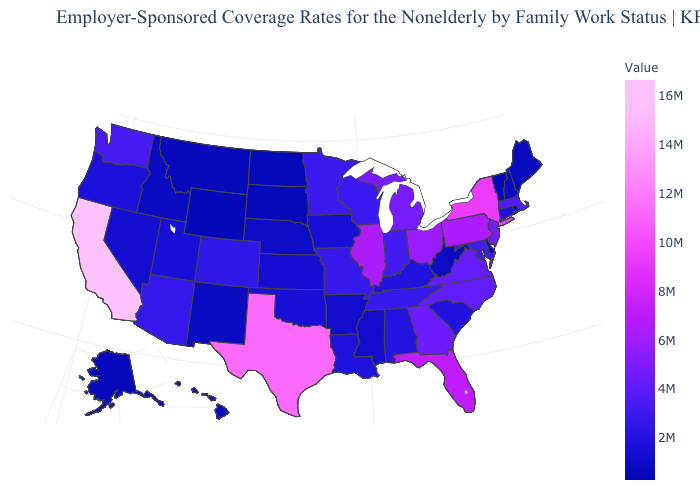Among the states that border Illinois , does Missouri have the highest value?
Be succinct. No. Among the states that border Utah , which have the highest value?
Answer briefly. Arizona. 